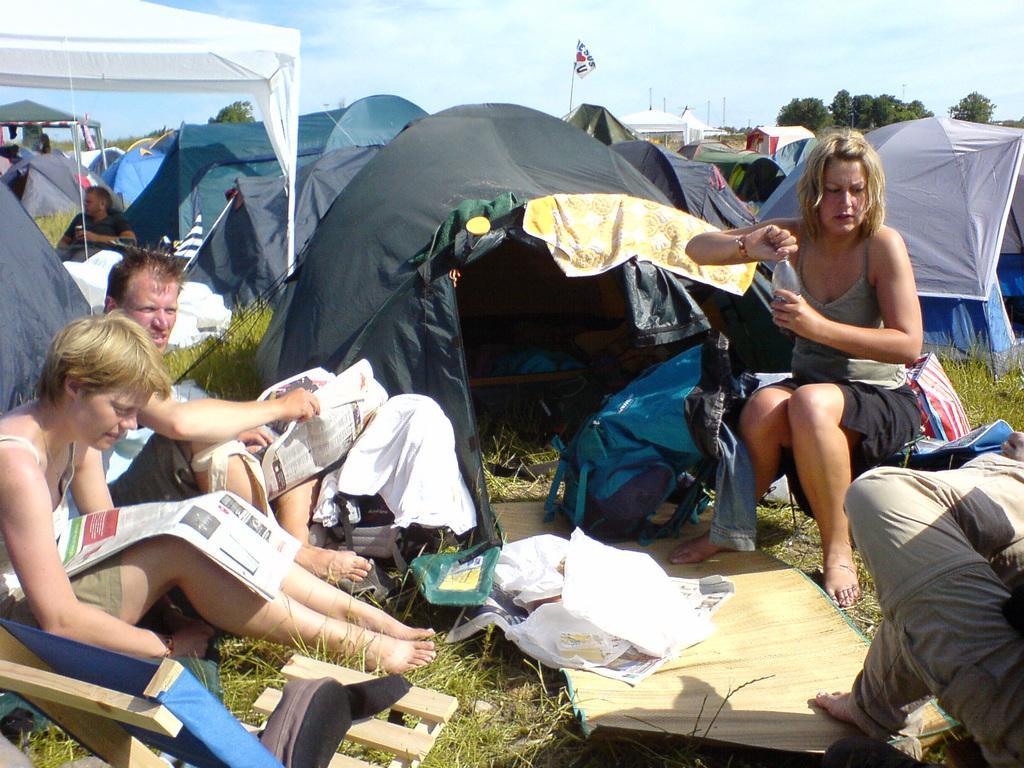How would you summarize this image in a sentence or two? In this image, we can see tents, trees, sheds, a flag and some clothes and there are people and some are holding newspapers and there is a lady holding a bottle and we can see a mat and bags and chairs. 